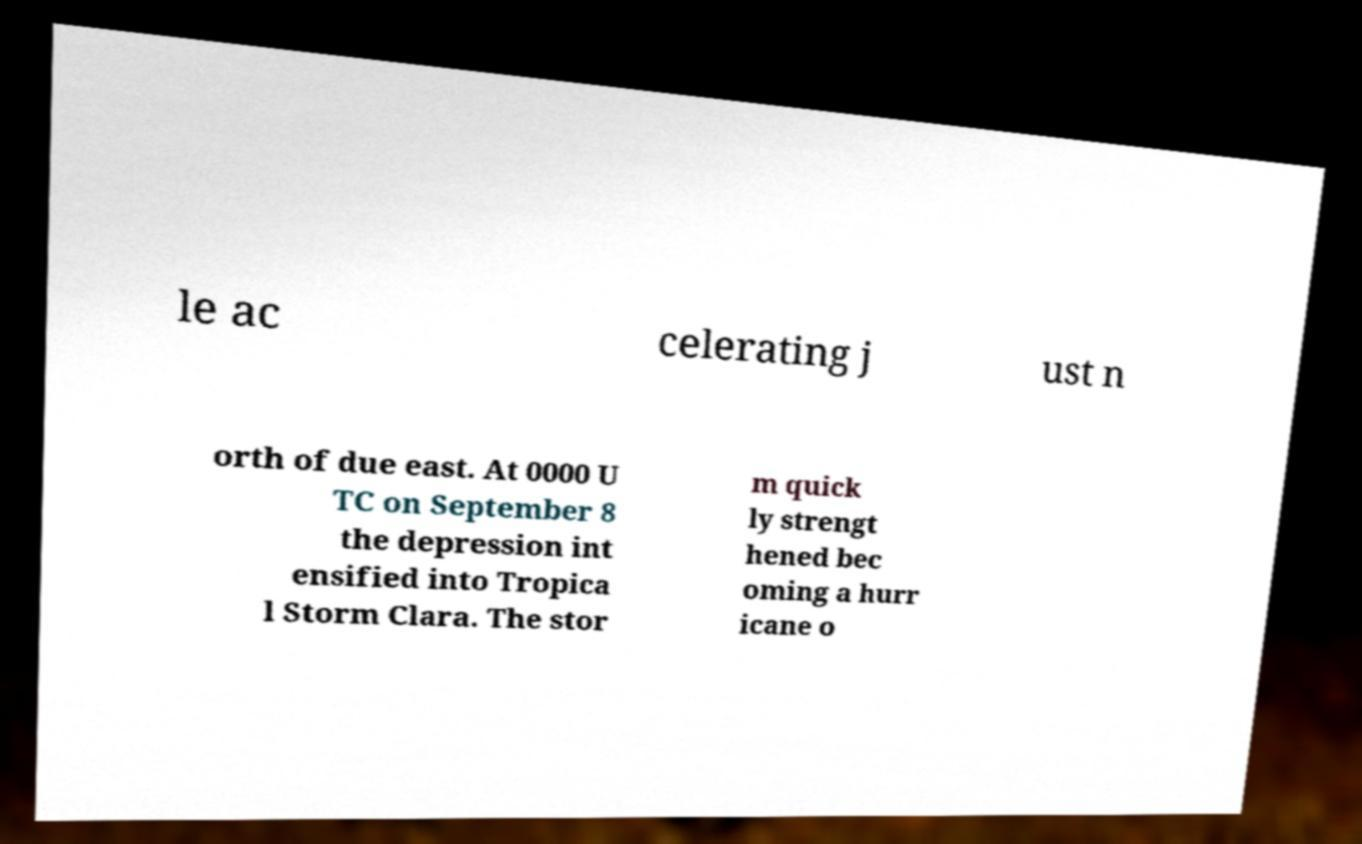There's text embedded in this image that I need extracted. Can you transcribe it verbatim? le ac celerating j ust n orth of due east. At 0000 U TC on September 8 the depression int ensified into Tropica l Storm Clara. The stor m quick ly strengt hened bec oming a hurr icane o 